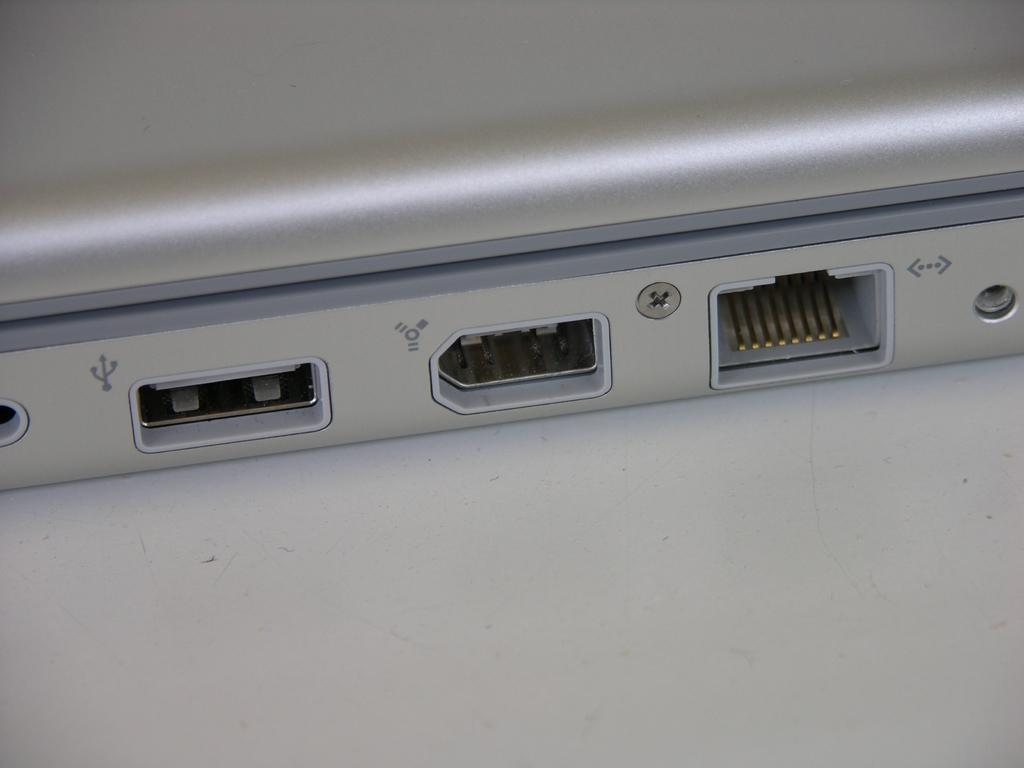What type of object is depicted in the image? The image contains ports of an electronic device. Can you describe the ports in the image? The specific details of the ports cannot be determined from the image alone, but they are part of an electronic device. Is there a girl involved in a fight in the image? No, there is no girl or fight present in the image; it only contains ports of an electronic device. 